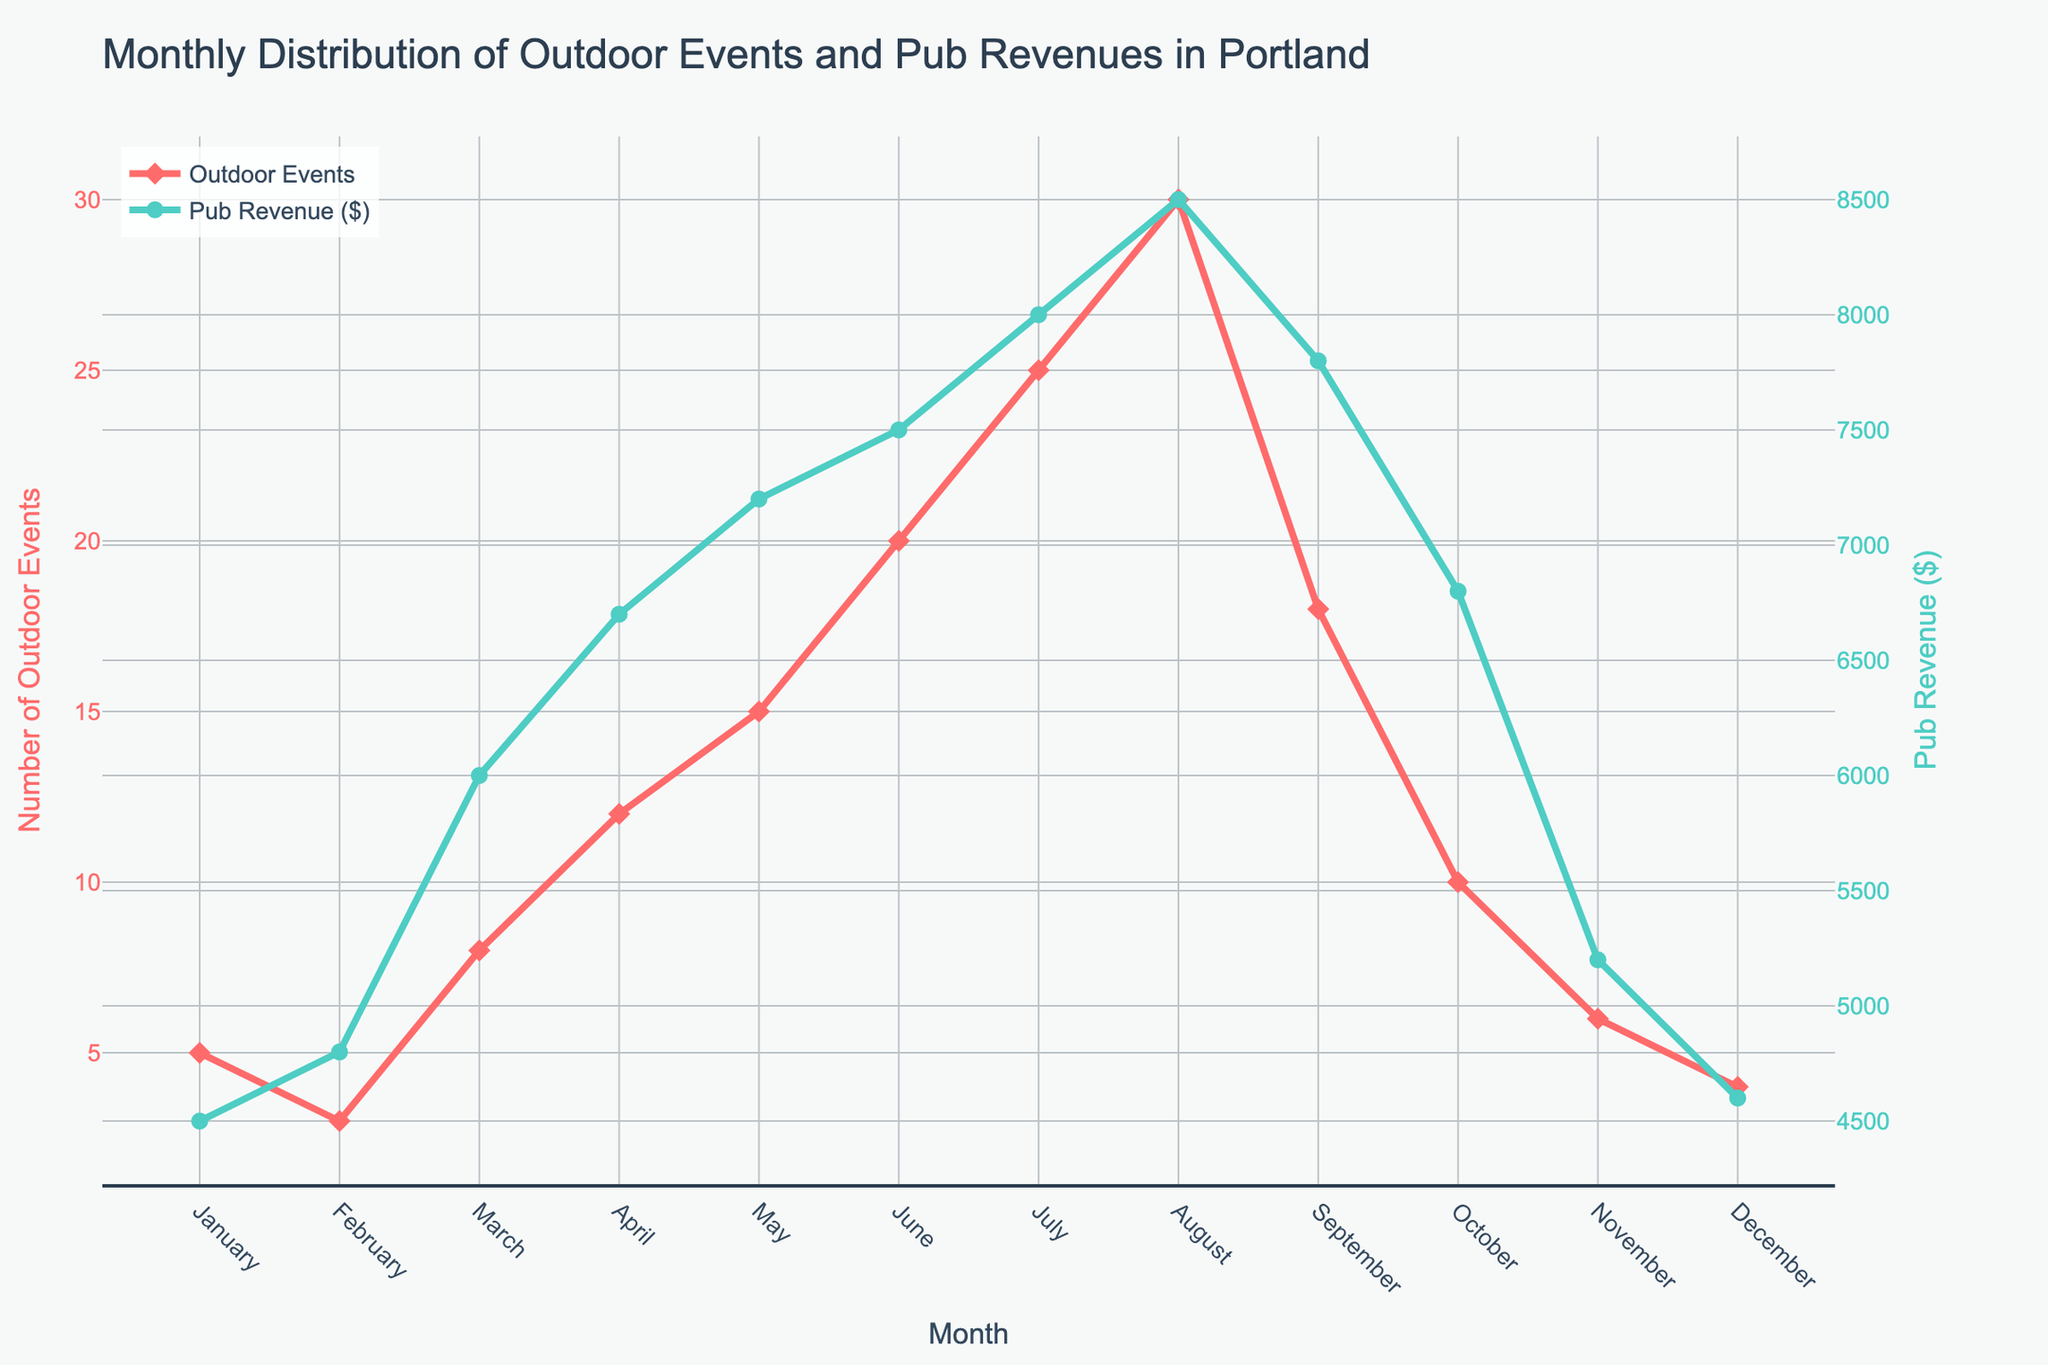What's the title of the figure? The title is prominently displayed at the top of the figure. It is "Monthly Distribution of Outdoor Events and Pub Revenues in Portland."
Answer: Monthly Distribution of Outdoor Events and Pub Revenues in Portland Which month had the highest number of outdoor events? The point corresponding to the highest number of outdoor events is the peak value on the "Outdoor Events" line. This peak occurs in August.
Answer: August When were pub revenues the highest? The highest point on the "Pub Revenue ($)" line indicates the month with the highest pub revenues. This occurs in August.
Answer: August How many outdoor events occurred in January? The plot shows that the number of outdoor events in January is 5, by looking at the marker on the "Outdoor Events" line for January.
Answer: 5 What is the pub revenue in February? By looking at the marker on the "Pub Revenue ($)" line for February, we can see that the revenue is $4800.
Answer: $4800 Compare the number of outdoor events in May and June. Which month had more? By comparing the markers on the "Outdoor Events" line for May and June, we see that June had 20 outdoor events, and May had 15. Therefore, June had more outdoor events.
Answer: June Calculate the average number of outdoor events for June, July, and August. Add the number of outdoor events for June (20), July (25), and August (30). Then divide by 3. So, (20 + 25 + 30) / 3 = 75 / 3 = 25.
Answer: 25 By how much did pub revenue increase from March to April? The difference in pub revenue between March ($6000) and April ($6700) is $6700 - $6000.
Answer: $700 Which month has a closer correlation between the number of outdoor events and pub revenue, April or October? April has 12 outdoor events and $6700 pub revenue, while October has 10 outdoor events and $6800 pub revenue. April shows a stronger correlation because the relative difference between events and revenue is smaller.
Answer: April Do the trends of outdoor events and pub revenue follow a similar pattern throughout the year? By observing the shape and peaks of both lines, we see that both tend to increase from January to August and then decrease from September to December, indicating they follow a similar pattern.
Answer: Yes 